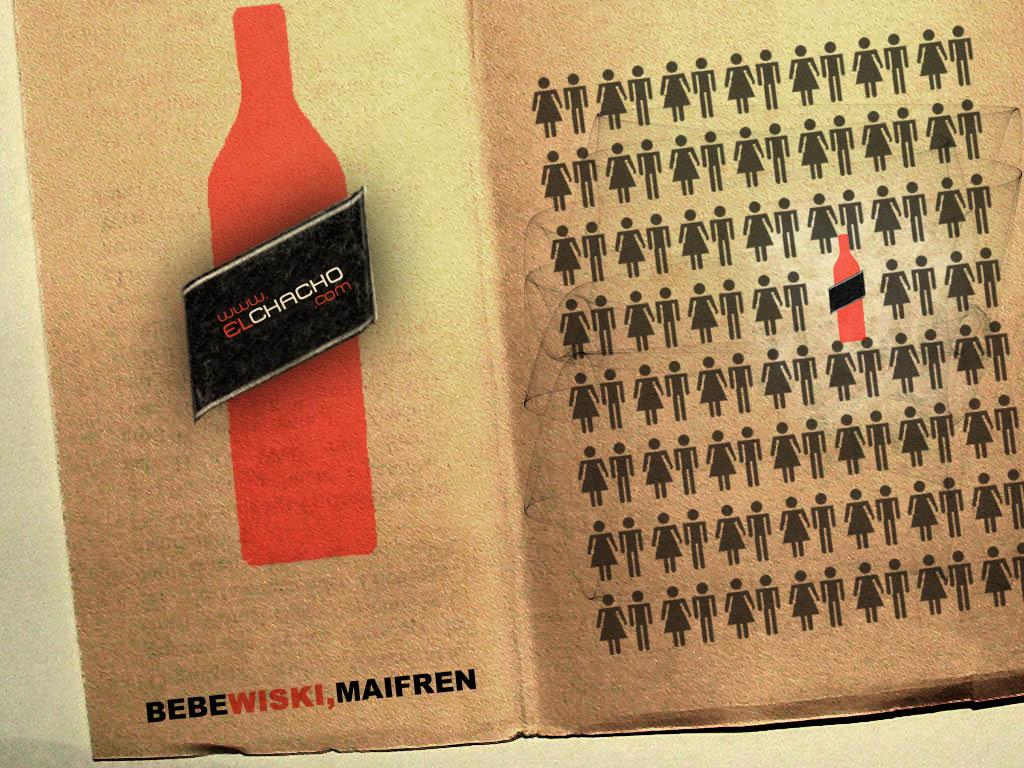Provide a one-sentence caption for the provided image. An advertisement for ww.elchacho.com, Bebewiski, Maifren has a sketch of a red bottle and men and women figures. 